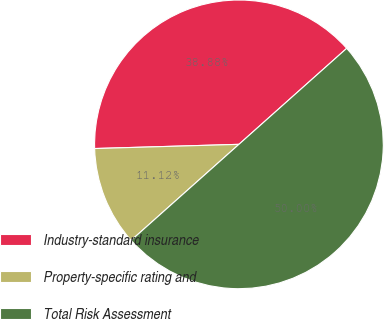Convert chart to OTSL. <chart><loc_0><loc_0><loc_500><loc_500><pie_chart><fcel>Industry-standard insurance<fcel>Property-specific rating and<fcel>Total Risk Assessment<nl><fcel>38.88%<fcel>11.12%<fcel>50.0%<nl></chart> 